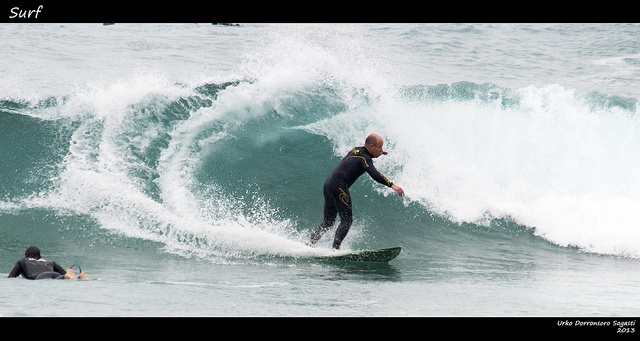Describe the objects in this image and their specific colors. I can see people in black, gray, darkgray, and lightgray tones, people in black, gray, and tan tones, surfboard in black, gray, and teal tones, and surfboard in black, darkgray, lightgray, and gray tones in this image. 